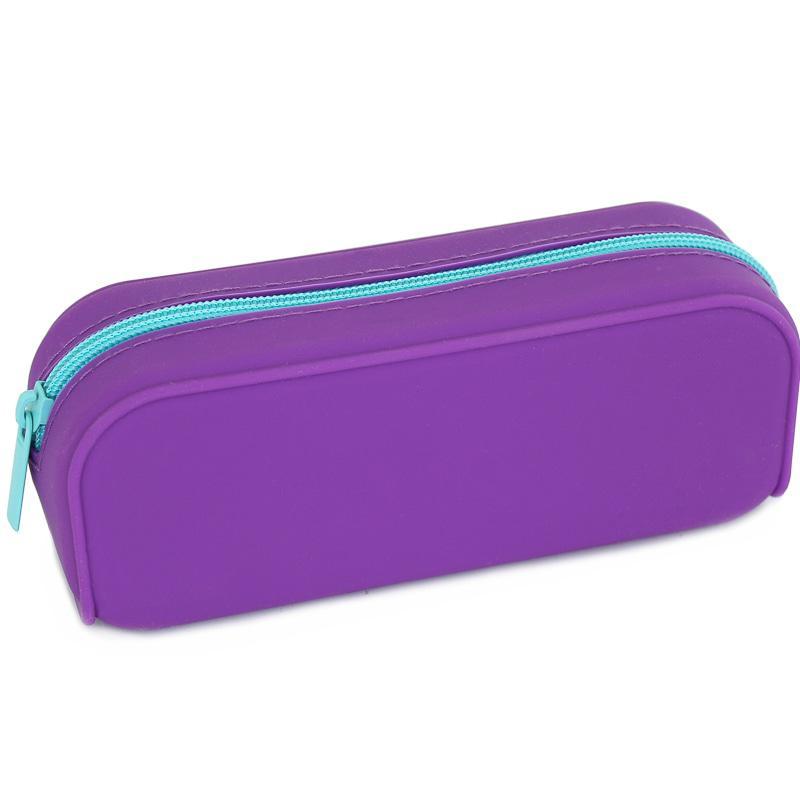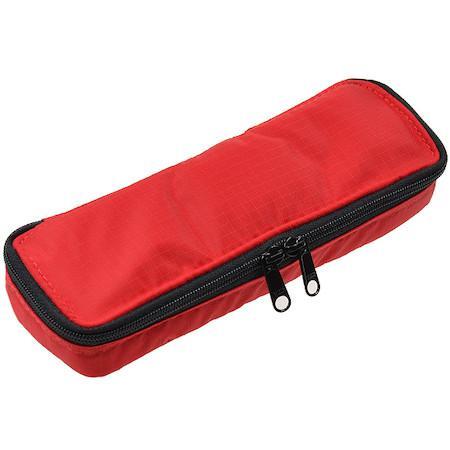The first image is the image on the left, the second image is the image on the right. For the images shown, is this caption "The right image contains a small red hand bag." true? Answer yes or no. Yes. The first image is the image on the left, the second image is the image on the right. Assess this claim about the two images: "One image contains a closed red zippered case without any writing implements near it.". Correct or not? Answer yes or no. Yes. 